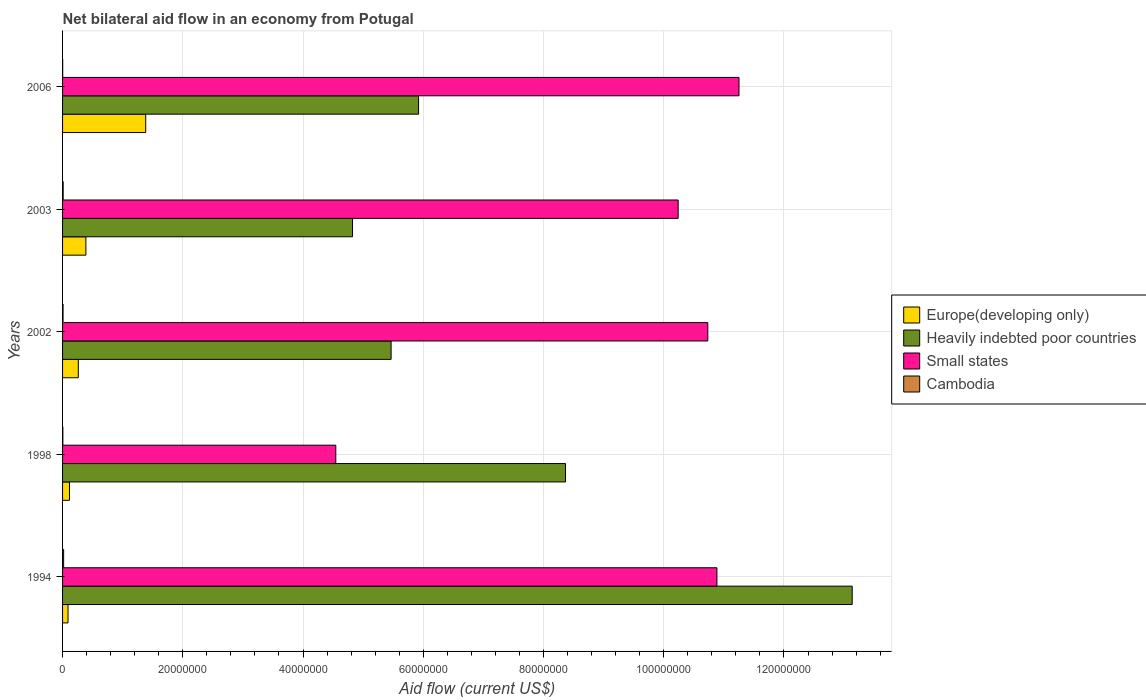How many different coloured bars are there?
Your response must be concise. 4. How many groups of bars are there?
Provide a short and direct response. 5. Are the number of bars on each tick of the Y-axis equal?
Your answer should be compact. Yes. How many bars are there on the 4th tick from the top?
Ensure brevity in your answer.  4. How many bars are there on the 5th tick from the bottom?
Offer a terse response. 4. What is the label of the 3rd group of bars from the top?
Provide a succinct answer. 2002. In how many cases, is the number of bars for a given year not equal to the number of legend labels?
Offer a very short reply. 0. What is the net bilateral aid flow in Small states in 1998?
Your response must be concise. 4.54e+07. Across all years, what is the maximum net bilateral aid flow in Heavily indebted poor countries?
Your response must be concise. 1.31e+08. Across all years, what is the minimum net bilateral aid flow in Europe(developing only)?
Offer a terse response. 9.10e+05. In which year was the net bilateral aid flow in Europe(developing only) maximum?
Provide a short and direct response. 2006. What is the total net bilateral aid flow in Europe(developing only) in the graph?
Give a very brief answer. 2.24e+07. What is the difference between the net bilateral aid flow in Cambodia in 2002 and that in 2006?
Make the answer very short. 6.00e+04. What is the difference between the net bilateral aid flow in Heavily indebted poor countries in 1998 and the net bilateral aid flow in Cambodia in 2002?
Your answer should be compact. 8.36e+07. What is the average net bilateral aid flow in Heavily indebted poor countries per year?
Make the answer very short. 7.54e+07. In the year 2003, what is the difference between the net bilateral aid flow in Small states and net bilateral aid flow in Europe(developing only)?
Keep it short and to the point. 9.85e+07. In how many years, is the net bilateral aid flow in Cambodia greater than 116000000 US$?
Ensure brevity in your answer.  0. Is the net bilateral aid flow in Heavily indebted poor countries in 2002 less than that in 2003?
Provide a short and direct response. No. Is the difference between the net bilateral aid flow in Small states in 1998 and 2006 greater than the difference between the net bilateral aid flow in Europe(developing only) in 1998 and 2006?
Provide a succinct answer. No. What is the difference between the highest and the second highest net bilateral aid flow in Small states?
Provide a succinct answer. 3.67e+06. What is the difference between the highest and the lowest net bilateral aid flow in Europe(developing only)?
Your response must be concise. 1.29e+07. Is the sum of the net bilateral aid flow in Europe(developing only) in 1994 and 2003 greater than the maximum net bilateral aid flow in Cambodia across all years?
Offer a very short reply. Yes. What does the 2nd bar from the top in 1998 represents?
Your answer should be compact. Small states. What does the 4th bar from the bottom in 2003 represents?
Offer a terse response. Cambodia. How many bars are there?
Ensure brevity in your answer.  20. Are all the bars in the graph horizontal?
Make the answer very short. Yes. How many years are there in the graph?
Keep it short and to the point. 5. Does the graph contain any zero values?
Offer a very short reply. No. How many legend labels are there?
Your answer should be compact. 4. What is the title of the graph?
Your answer should be compact. Net bilateral aid flow in an economy from Potugal. What is the label or title of the Y-axis?
Offer a very short reply. Years. What is the Aid flow (current US$) in Europe(developing only) in 1994?
Keep it short and to the point. 9.10e+05. What is the Aid flow (current US$) of Heavily indebted poor countries in 1994?
Offer a very short reply. 1.31e+08. What is the Aid flow (current US$) in Small states in 1994?
Provide a succinct answer. 1.09e+08. What is the Aid flow (current US$) of Europe(developing only) in 1998?
Offer a very short reply. 1.15e+06. What is the Aid flow (current US$) of Heavily indebted poor countries in 1998?
Give a very brief answer. 8.37e+07. What is the Aid flow (current US$) in Small states in 1998?
Provide a short and direct response. 4.54e+07. What is the Aid flow (current US$) of Cambodia in 1998?
Offer a terse response. 5.00e+04. What is the Aid flow (current US$) of Europe(developing only) in 2002?
Provide a succinct answer. 2.62e+06. What is the Aid flow (current US$) in Heavily indebted poor countries in 2002?
Offer a terse response. 5.46e+07. What is the Aid flow (current US$) in Small states in 2002?
Keep it short and to the point. 1.07e+08. What is the Aid flow (current US$) in Europe(developing only) in 2003?
Offer a very short reply. 3.88e+06. What is the Aid flow (current US$) in Heavily indebted poor countries in 2003?
Offer a terse response. 4.82e+07. What is the Aid flow (current US$) in Small states in 2003?
Make the answer very short. 1.02e+08. What is the Aid flow (current US$) in Cambodia in 2003?
Your answer should be very brief. 1.00e+05. What is the Aid flow (current US$) of Europe(developing only) in 2006?
Offer a very short reply. 1.38e+07. What is the Aid flow (current US$) of Heavily indebted poor countries in 2006?
Your answer should be compact. 5.92e+07. What is the Aid flow (current US$) of Small states in 2006?
Your answer should be compact. 1.13e+08. Across all years, what is the maximum Aid flow (current US$) in Europe(developing only)?
Provide a short and direct response. 1.38e+07. Across all years, what is the maximum Aid flow (current US$) in Heavily indebted poor countries?
Make the answer very short. 1.31e+08. Across all years, what is the maximum Aid flow (current US$) in Small states?
Ensure brevity in your answer.  1.13e+08. Across all years, what is the maximum Aid flow (current US$) in Cambodia?
Offer a terse response. 1.80e+05. Across all years, what is the minimum Aid flow (current US$) in Europe(developing only)?
Ensure brevity in your answer.  9.10e+05. Across all years, what is the minimum Aid flow (current US$) of Heavily indebted poor countries?
Make the answer very short. 4.82e+07. Across all years, what is the minimum Aid flow (current US$) of Small states?
Provide a short and direct response. 4.54e+07. What is the total Aid flow (current US$) in Europe(developing only) in the graph?
Offer a very short reply. 2.24e+07. What is the total Aid flow (current US$) of Heavily indebted poor countries in the graph?
Provide a succinct answer. 3.77e+08. What is the total Aid flow (current US$) of Small states in the graph?
Offer a very short reply. 4.77e+08. What is the difference between the Aid flow (current US$) in Heavily indebted poor countries in 1994 and that in 1998?
Give a very brief answer. 4.77e+07. What is the difference between the Aid flow (current US$) in Small states in 1994 and that in 1998?
Give a very brief answer. 6.34e+07. What is the difference between the Aid flow (current US$) in Europe(developing only) in 1994 and that in 2002?
Make the answer very short. -1.71e+06. What is the difference between the Aid flow (current US$) in Heavily indebted poor countries in 1994 and that in 2002?
Your response must be concise. 7.67e+07. What is the difference between the Aid flow (current US$) in Small states in 1994 and that in 2002?
Keep it short and to the point. 1.52e+06. What is the difference between the Aid flow (current US$) in Cambodia in 1994 and that in 2002?
Ensure brevity in your answer.  1.00e+05. What is the difference between the Aid flow (current US$) of Europe(developing only) in 1994 and that in 2003?
Offer a terse response. -2.97e+06. What is the difference between the Aid flow (current US$) in Heavily indebted poor countries in 1994 and that in 2003?
Offer a terse response. 8.31e+07. What is the difference between the Aid flow (current US$) in Small states in 1994 and that in 2003?
Give a very brief answer. 6.45e+06. What is the difference between the Aid flow (current US$) in Europe(developing only) in 1994 and that in 2006?
Your answer should be very brief. -1.29e+07. What is the difference between the Aid flow (current US$) of Heavily indebted poor countries in 1994 and that in 2006?
Offer a terse response. 7.21e+07. What is the difference between the Aid flow (current US$) in Small states in 1994 and that in 2006?
Your response must be concise. -3.67e+06. What is the difference between the Aid flow (current US$) in Europe(developing only) in 1998 and that in 2002?
Give a very brief answer. -1.47e+06. What is the difference between the Aid flow (current US$) in Heavily indebted poor countries in 1998 and that in 2002?
Your answer should be very brief. 2.90e+07. What is the difference between the Aid flow (current US$) of Small states in 1998 and that in 2002?
Your answer should be very brief. -6.19e+07. What is the difference between the Aid flow (current US$) in Europe(developing only) in 1998 and that in 2003?
Your response must be concise. -2.73e+06. What is the difference between the Aid flow (current US$) of Heavily indebted poor countries in 1998 and that in 2003?
Your answer should be very brief. 3.54e+07. What is the difference between the Aid flow (current US$) of Small states in 1998 and that in 2003?
Keep it short and to the point. -5.70e+07. What is the difference between the Aid flow (current US$) of Cambodia in 1998 and that in 2003?
Keep it short and to the point. -5.00e+04. What is the difference between the Aid flow (current US$) in Europe(developing only) in 1998 and that in 2006?
Provide a succinct answer. -1.27e+07. What is the difference between the Aid flow (current US$) of Heavily indebted poor countries in 1998 and that in 2006?
Your response must be concise. 2.44e+07. What is the difference between the Aid flow (current US$) of Small states in 1998 and that in 2006?
Provide a succinct answer. -6.71e+07. What is the difference between the Aid flow (current US$) of Cambodia in 1998 and that in 2006?
Offer a very short reply. 3.00e+04. What is the difference between the Aid flow (current US$) in Europe(developing only) in 2002 and that in 2003?
Make the answer very short. -1.26e+06. What is the difference between the Aid flow (current US$) of Heavily indebted poor countries in 2002 and that in 2003?
Your answer should be very brief. 6.42e+06. What is the difference between the Aid flow (current US$) of Small states in 2002 and that in 2003?
Provide a short and direct response. 4.93e+06. What is the difference between the Aid flow (current US$) in Europe(developing only) in 2002 and that in 2006?
Your answer should be compact. -1.12e+07. What is the difference between the Aid flow (current US$) of Heavily indebted poor countries in 2002 and that in 2006?
Provide a short and direct response. -4.57e+06. What is the difference between the Aid flow (current US$) of Small states in 2002 and that in 2006?
Offer a terse response. -5.19e+06. What is the difference between the Aid flow (current US$) in Europe(developing only) in 2003 and that in 2006?
Make the answer very short. -9.95e+06. What is the difference between the Aid flow (current US$) in Heavily indebted poor countries in 2003 and that in 2006?
Keep it short and to the point. -1.10e+07. What is the difference between the Aid flow (current US$) in Small states in 2003 and that in 2006?
Your answer should be very brief. -1.01e+07. What is the difference between the Aid flow (current US$) in Europe(developing only) in 1994 and the Aid flow (current US$) in Heavily indebted poor countries in 1998?
Offer a very short reply. -8.28e+07. What is the difference between the Aid flow (current US$) of Europe(developing only) in 1994 and the Aid flow (current US$) of Small states in 1998?
Offer a terse response. -4.45e+07. What is the difference between the Aid flow (current US$) in Europe(developing only) in 1994 and the Aid flow (current US$) in Cambodia in 1998?
Your answer should be compact. 8.60e+05. What is the difference between the Aid flow (current US$) of Heavily indebted poor countries in 1994 and the Aid flow (current US$) of Small states in 1998?
Give a very brief answer. 8.59e+07. What is the difference between the Aid flow (current US$) in Heavily indebted poor countries in 1994 and the Aid flow (current US$) in Cambodia in 1998?
Provide a short and direct response. 1.31e+08. What is the difference between the Aid flow (current US$) of Small states in 1994 and the Aid flow (current US$) of Cambodia in 1998?
Ensure brevity in your answer.  1.09e+08. What is the difference between the Aid flow (current US$) of Europe(developing only) in 1994 and the Aid flow (current US$) of Heavily indebted poor countries in 2002?
Offer a terse response. -5.37e+07. What is the difference between the Aid flow (current US$) in Europe(developing only) in 1994 and the Aid flow (current US$) in Small states in 2002?
Your answer should be compact. -1.06e+08. What is the difference between the Aid flow (current US$) of Europe(developing only) in 1994 and the Aid flow (current US$) of Cambodia in 2002?
Provide a succinct answer. 8.30e+05. What is the difference between the Aid flow (current US$) in Heavily indebted poor countries in 1994 and the Aid flow (current US$) in Small states in 2002?
Offer a very short reply. 2.40e+07. What is the difference between the Aid flow (current US$) of Heavily indebted poor countries in 1994 and the Aid flow (current US$) of Cambodia in 2002?
Give a very brief answer. 1.31e+08. What is the difference between the Aid flow (current US$) of Small states in 1994 and the Aid flow (current US$) of Cambodia in 2002?
Give a very brief answer. 1.09e+08. What is the difference between the Aid flow (current US$) of Europe(developing only) in 1994 and the Aid flow (current US$) of Heavily indebted poor countries in 2003?
Your answer should be compact. -4.73e+07. What is the difference between the Aid flow (current US$) in Europe(developing only) in 1994 and the Aid flow (current US$) in Small states in 2003?
Provide a succinct answer. -1.01e+08. What is the difference between the Aid flow (current US$) in Europe(developing only) in 1994 and the Aid flow (current US$) in Cambodia in 2003?
Keep it short and to the point. 8.10e+05. What is the difference between the Aid flow (current US$) in Heavily indebted poor countries in 1994 and the Aid flow (current US$) in Small states in 2003?
Provide a succinct answer. 2.90e+07. What is the difference between the Aid flow (current US$) in Heavily indebted poor countries in 1994 and the Aid flow (current US$) in Cambodia in 2003?
Your answer should be very brief. 1.31e+08. What is the difference between the Aid flow (current US$) in Small states in 1994 and the Aid flow (current US$) in Cambodia in 2003?
Provide a succinct answer. 1.09e+08. What is the difference between the Aid flow (current US$) of Europe(developing only) in 1994 and the Aid flow (current US$) of Heavily indebted poor countries in 2006?
Keep it short and to the point. -5.83e+07. What is the difference between the Aid flow (current US$) in Europe(developing only) in 1994 and the Aid flow (current US$) in Small states in 2006?
Make the answer very short. -1.12e+08. What is the difference between the Aid flow (current US$) in Europe(developing only) in 1994 and the Aid flow (current US$) in Cambodia in 2006?
Your answer should be very brief. 8.90e+05. What is the difference between the Aid flow (current US$) of Heavily indebted poor countries in 1994 and the Aid flow (current US$) of Small states in 2006?
Offer a terse response. 1.88e+07. What is the difference between the Aid flow (current US$) in Heavily indebted poor countries in 1994 and the Aid flow (current US$) in Cambodia in 2006?
Your answer should be compact. 1.31e+08. What is the difference between the Aid flow (current US$) of Small states in 1994 and the Aid flow (current US$) of Cambodia in 2006?
Keep it short and to the point. 1.09e+08. What is the difference between the Aid flow (current US$) in Europe(developing only) in 1998 and the Aid flow (current US$) in Heavily indebted poor countries in 2002?
Provide a short and direct response. -5.35e+07. What is the difference between the Aid flow (current US$) of Europe(developing only) in 1998 and the Aid flow (current US$) of Small states in 2002?
Keep it short and to the point. -1.06e+08. What is the difference between the Aid flow (current US$) of Europe(developing only) in 1998 and the Aid flow (current US$) of Cambodia in 2002?
Your answer should be very brief. 1.07e+06. What is the difference between the Aid flow (current US$) of Heavily indebted poor countries in 1998 and the Aid flow (current US$) of Small states in 2002?
Give a very brief answer. -2.37e+07. What is the difference between the Aid flow (current US$) in Heavily indebted poor countries in 1998 and the Aid flow (current US$) in Cambodia in 2002?
Make the answer very short. 8.36e+07. What is the difference between the Aid flow (current US$) of Small states in 1998 and the Aid flow (current US$) of Cambodia in 2002?
Make the answer very short. 4.54e+07. What is the difference between the Aid flow (current US$) of Europe(developing only) in 1998 and the Aid flow (current US$) of Heavily indebted poor countries in 2003?
Your response must be concise. -4.71e+07. What is the difference between the Aid flow (current US$) of Europe(developing only) in 1998 and the Aid flow (current US$) of Small states in 2003?
Make the answer very short. -1.01e+08. What is the difference between the Aid flow (current US$) in Europe(developing only) in 1998 and the Aid flow (current US$) in Cambodia in 2003?
Ensure brevity in your answer.  1.05e+06. What is the difference between the Aid flow (current US$) of Heavily indebted poor countries in 1998 and the Aid flow (current US$) of Small states in 2003?
Keep it short and to the point. -1.87e+07. What is the difference between the Aid flow (current US$) of Heavily indebted poor countries in 1998 and the Aid flow (current US$) of Cambodia in 2003?
Your answer should be very brief. 8.36e+07. What is the difference between the Aid flow (current US$) of Small states in 1998 and the Aid flow (current US$) of Cambodia in 2003?
Your response must be concise. 4.54e+07. What is the difference between the Aid flow (current US$) of Europe(developing only) in 1998 and the Aid flow (current US$) of Heavily indebted poor countries in 2006?
Offer a very short reply. -5.81e+07. What is the difference between the Aid flow (current US$) of Europe(developing only) in 1998 and the Aid flow (current US$) of Small states in 2006?
Keep it short and to the point. -1.11e+08. What is the difference between the Aid flow (current US$) in Europe(developing only) in 1998 and the Aid flow (current US$) in Cambodia in 2006?
Ensure brevity in your answer.  1.13e+06. What is the difference between the Aid flow (current US$) of Heavily indebted poor countries in 1998 and the Aid flow (current US$) of Small states in 2006?
Provide a short and direct response. -2.89e+07. What is the difference between the Aid flow (current US$) in Heavily indebted poor countries in 1998 and the Aid flow (current US$) in Cambodia in 2006?
Give a very brief answer. 8.36e+07. What is the difference between the Aid flow (current US$) in Small states in 1998 and the Aid flow (current US$) in Cambodia in 2006?
Ensure brevity in your answer.  4.54e+07. What is the difference between the Aid flow (current US$) in Europe(developing only) in 2002 and the Aid flow (current US$) in Heavily indebted poor countries in 2003?
Give a very brief answer. -4.56e+07. What is the difference between the Aid flow (current US$) in Europe(developing only) in 2002 and the Aid flow (current US$) in Small states in 2003?
Your response must be concise. -9.98e+07. What is the difference between the Aid flow (current US$) in Europe(developing only) in 2002 and the Aid flow (current US$) in Cambodia in 2003?
Provide a succinct answer. 2.52e+06. What is the difference between the Aid flow (current US$) in Heavily indebted poor countries in 2002 and the Aid flow (current US$) in Small states in 2003?
Your response must be concise. -4.78e+07. What is the difference between the Aid flow (current US$) in Heavily indebted poor countries in 2002 and the Aid flow (current US$) in Cambodia in 2003?
Offer a very short reply. 5.46e+07. What is the difference between the Aid flow (current US$) in Small states in 2002 and the Aid flow (current US$) in Cambodia in 2003?
Ensure brevity in your answer.  1.07e+08. What is the difference between the Aid flow (current US$) of Europe(developing only) in 2002 and the Aid flow (current US$) of Heavily indebted poor countries in 2006?
Provide a succinct answer. -5.66e+07. What is the difference between the Aid flow (current US$) of Europe(developing only) in 2002 and the Aid flow (current US$) of Small states in 2006?
Your answer should be compact. -1.10e+08. What is the difference between the Aid flow (current US$) in Europe(developing only) in 2002 and the Aid flow (current US$) in Cambodia in 2006?
Offer a very short reply. 2.60e+06. What is the difference between the Aid flow (current US$) of Heavily indebted poor countries in 2002 and the Aid flow (current US$) of Small states in 2006?
Keep it short and to the point. -5.79e+07. What is the difference between the Aid flow (current US$) of Heavily indebted poor countries in 2002 and the Aid flow (current US$) of Cambodia in 2006?
Keep it short and to the point. 5.46e+07. What is the difference between the Aid flow (current US$) of Small states in 2002 and the Aid flow (current US$) of Cambodia in 2006?
Your answer should be very brief. 1.07e+08. What is the difference between the Aid flow (current US$) in Europe(developing only) in 2003 and the Aid flow (current US$) in Heavily indebted poor countries in 2006?
Provide a succinct answer. -5.53e+07. What is the difference between the Aid flow (current US$) in Europe(developing only) in 2003 and the Aid flow (current US$) in Small states in 2006?
Make the answer very short. -1.09e+08. What is the difference between the Aid flow (current US$) in Europe(developing only) in 2003 and the Aid flow (current US$) in Cambodia in 2006?
Ensure brevity in your answer.  3.86e+06. What is the difference between the Aid flow (current US$) of Heavily indebted poor countries in 2003 and the Aid flow (current US$) of Small states in 2006?
Give a very brief answer. -6.43e+07. What is the difference between the Aid flow (current US$) of Heavily indebted poor countries in 2003 and the Aid flow (current US$) of Cambodia in 2006?
Offer a very short reply. 4.82e+07. What is the difference between the Aid flow (current US$) of Small states in 2003 and the Aid flow (current US$) of Cambodia in 2006?
Give a very brief answer. 1.02e+08. What is the average Aid flow (current US$) of Europe(developing only) per year?
Make the answer very short. 4.48e+06. What is the average Aid flow (current US$) of Heavily indebted poor countries per year?
Provide a succinct answer. 7.54e+07. What is the average Aid flow (current US$) in Small states per year?
Ensure brevity in your answer.  9.53e+07. What is the average Aid flow (current US$) of Cambodia per year?
Offer a terse response. 8.60e+04. In the year 1994, what is the difference between the Aid flow (current US$) of Europe(developing only) and Aid flow (current US$) of Heavily indebted poor countries?
Your response must be concise. -1.30e+08. In the year 1994, what is the difference between the Aid flow (current US$) of Europe(developing only) and Aid flow (current US$) of Small states?
Give a very brief answer. -1.08e+08. In the year 1994, what is the difference between the Aid flow (current US$) in Europe(developing only) and Aid flow (current US$) in Cambodia?
Your response must be concise. 7.30e+05. In the year 1994, what is the difference between the Aid flow (current US$) of Heavily indebted poor countries and Aid flow (current US$) of Small states?
Offer a terse response. 2.25e+07. In the year 1994, what is the difference between the Aid flow (current US$) in Heavily indebted poor countries and Aid flow (current US$) in Cambodia?
Keep it short and to the point. 1.31e+08. In the year 1994, what is the difference between the Aid flow (current US$) of Small states and Aid flow (current US$) of Cambodia?
Your answer should be compact. 1.09e+08. In the year 1998, what is the difference between the Aid flow (current US$) in Europe(developing only) and Aid flow (current US$) in Heavily indebted poor countries?
Provide a succinct answer. -8.25e+07. In the year 1998, what is the difference between the Aid flow (current US$) in Europe(developing only) and Aid flow (current US$) in Small states?
Make the answer very short. -4.43e+07. In the year 1998, what is the difference between the Aid flow (current US$) in Europe(developing only) and Aid flow (current US$) in Cambodia?
Keep it short and to the point. 1.10e+06. In the year 1998, what is the difference between the Aid flow (current US$) of Heavily indebted poor countries and Aid flow (current US$) of Small states?
Keep it short and to the point. 3.82e+07. In the year 1998, what is the difference between the Aid flow (current US$) of Heavily indebted poor countries and Aid flow (current US$) of Cambodia?
Your answer should be very brief. 8.36e+07. In the year 1998, what is the difference between the Aid flow (current US$) in Small states and Aid flow (current US$) in Cambodia?
Provide a succinct answer. 4.54e+07. In the year 2002, what is the difference between the Aid flow (current US$) of Europe(developing only) and Aid flow (current US$) of Heavily indebted poor countries?
Offer a very short reply. -5.20e+07. In the year 2002, what is the difference between the Aid flow (current US$) of Europe(developing only) and Aid flow (current US$) of Small states?
Provide a succinct answer. -1.05e+08. In the year 2002, what is the difference between the Aid flow (current US$) of Europe(developing only) and Aid flow (current US$) of Cambodia?
Give a very brief answer. 2.54e+06. In the year 2002, what is the difference between the Aid flow (current US$) in Heavily indebted poor countries and Aid flow (current US$) in Small states?
Make the answer very short. -5.27e+07. In the year 2002, what is the difference between the Aid flow (current US$) in Heavily indebted poor countries and Aid flow (current US$) in Cambodia?
Your answer should be very brief. 5.46e+07. In the year 2002, what is the difference between the Aid flow (current US$) of Small states and Aid flow (current US$) of Cambodia?
Your answer should be very brief. 1.07e+08. In the year 2003, what is the difference between the Aid flow (current US$) in Europe(developing only) and Aid flow (current US$) in Heavily indebted poor countries?
Make the answer very short. -4.44e+07. In the year 2003, what is the difference between the Aid flow (current US$) in Europe(developing only) and Aid flow (current US$) in Small states?
Offer a terse response. -9.85e+07. In the year 2003, what is the difference between the Aid flow (current US$) in Europe(developing only) and Aid flow (current US$) in Cambodia?
Provide a succinct answer. 3.78e+06. In the year 2003, what is the difference between the Aid flow (current US$) in Heavily indebted poor countries and Aid flow (current US$) in Small states?
Keep it short and to the point. -5.42e+07. In the year 2003, what is the difference between the Aid flow (current US$) in Heavily indebted poor countries and Aid flow (current US$) in Cambodia?
Your response must be concise. 4.81e+07. In the year 2003, what is the difference between the Aid flow (current US$) of Small states and Aid flow (current US$) of Cambodia?
Your answer should be compact. 1.02e+08. In the year 2006, what is the difference between the Aid flow (current US$) of Europe(developing only) and Aid flow (current US$) of Heavily indebted poor countries?
Give a very brief answer. -4.54e+07. In the year 2006, what is the difference between the Aid flow (current US$) in Europe(developing only) and Aid flow (current US$) in Small states?
Keep it short and to the point. -9.87e+07. In the year 2006, what is the difference between the Aid flow (current US$) in Europe(developing only) and Aid flow (current US$) in Cambodia?
Ensure brevity in your answer.  1.38e+07. In the year 2006, what is the difference between the Aid flow (current US$) of Heavily indebted poor countries and Aid flow (current US$) of Small states?
Your answer should be very brief. -5.33e+07. In the year 2006, what is the difference between the Aid flow (current US$) in Heavily indebted poor countries and Aid flow (current US$) in Cambodia?
Provide a short and direct response. 5.92e+07. In the year 2006, what is the difference between the Aid flow (current US$) of Small states and Aid flow (current US$) of Cambodia?
Ensure brevity in your answer.  1.12e+08. What is the ratio of the Aid flow (current US$) in Europe(developing only) in 1994 to that in 1998?
Offer a very short reply. 0.79. What is the ratio of the Aid flow (current US$) in Heavily indebted poor countries in 1994 to that in 1998?
Offer a very short reply. 1.57. What is the ratio of the Aid flow (current US$) of Small states in 1994 to that in 1998?
Provide a short and direct response. 2.39. What is the ratio of the Aid flow (current US$) in Europe(developing only) in 1994 to that in 2002?
Make the answer very short. 0.35. What is the ratio of the Aid flow (current US$) of Heavily indebted poor countries in 1994 to that in 2002?
Your response must be concise. 2.4. What is the ratio of the Aid flow (current US$) in Small states in 1994 to that in 2002?
Offer a terse response. 1.01. What is the ratio of the Aid flow (current US$) in Cambodia in 1994 to that in 2002?
Provide a short and direct response. 2.25. What is the ratio of the Aid flow (current US$) of Europe(developing only) in 1994 to that in 2003?
Offer a terse response. 0.23. What is the ratio of the Aid flow (current US$) in Heavily indebted poor countries in 1994 to that in 2003?
Give a very brief answer. 2.72. What is the ratio of the Aid flow (current US$) in Small states in 1994 to that in 2003?
Offer a terse response. 1.06. What is the ratio of the Aid flow (current US$) of Cambodia in 1994 to that in 2003?
Offer a very short reply. 1.8. What is the ratio of the Aid flow (current US$) of Europe(developing only) in 1994 to that in 2006?
Make the answer very short. 0.07. What is the ratio of the Aid flow (current US$) of Heavily indebted poor countries in 1994 to that in 2006?
Give a very brief answer. 2.22. What is the ratio of the Aid flow (current US$) of Small states in 1994 to that in 2006?
Ensure brevity in your answer.  0.97. What is the ratio of the Aid flow (current US$) in Europe(developing only) in 1998 to that in 2002?
Make the answer very short. 0.44. What is the ratio of the Aid flow (current US$) of Heavily indebted poor countries in 1998 to that in 2002?
Ensure brevity in your answer.  1.53. What is the ratio of the Aid flow (current US$) of Small states in 1998 to that in 2002?
Make the answer very short. 0.42. What is the ratio of the Aid flow (current US$) in Cambodia in 1998 to that in 2002?
Provide a succinct answer. 0.62. What is the ratio of the Aid flow (current US$) of Europe(developing only) in 1998 to that in 2003?
Provide a short and direct response. 0.3. What is the ratio of the Aid flow (current US$) in Heavily indebted poor countries in 1998 to that in 2003?
Make the answer very short. 1.73. What is the ratio of the Aid flow (current US$) of Small states in 1998 to that in 2003?
Keep it short and to the point. 0.44. What is the ratio of the Aid flow (current US$) of Europe(developing only) in 1998 to that in 2006?
Provide a short and direct response. 0.08. What is the ratio of the Aid flow (current US$) of Heavily indebted poor countries in 1998 to that in 2006?
Keep it short and to the point. 1.41. What is the ratio of the Aid flow (current US$) in Small states in 1998 to that in 2006?
Offer a terse response. 0.4. What is the ratio of the Aid flow (current US$) in Europe(developing only) in 2002 to that in 2003?
Ensure brevity in your answer.  0.68. What is the ratio of the Aid flow (current US$) of Heavily indebted poor countries in 2002 to that in 2003?
Provide a succinct answer. 1.13. What is the ratio of the Aid flow (current US$) of Small states in 2002 to that in 2003?
Give a very brief answer. 1.05. What is the ratio of the Aid flow (current US$) of Cambodia in 2002 to that in 2003?
Make the answer very short. 0.8. What is the ratio of the Aid flow (current US$) in Europe(developing only) in 2002 to that in 2006?
Offer a very short reply. 0.19. What is the ratio of the Aid flow (current US$) of Heavily indebted poor countries in 2002 to that in 2006?
Your answer should be compact. 0.92. What is the ratio of the Aid flow (current US$) of Small states in 2002 to that in 2006?
Make the answer very short. 0.95. What is the ratio of the Aid flow (current US$) of Cambodia in 2002 to that in 2006?
Provide a short and direct response. 4. What is the ratio of the Aid flow (current US$) of Europe(developing only) in 2003 to that in 2006?
Offer a terse response. 0.28. What is the ratio of the Aid flow (current US$) of Heavily indebted poor countries in 2003 to that in 2006?
Make the answer very short. 0.81. What is the ratio of the Aid flow (current US$) of Small states in 2003 to that in 2006?
Your answer should be very brief. 0.91. What is the ratio of the Aid flow (current US$) of Cambodia in 2003 to that in 2006?
Ensure brevity in your answer.  5. What is the difference between the highest and the second highest Aid flow (current US$) in Europe(developing only)?
Ensure brevity in your answer.  9.95e+06. What is the difference between the highest and the second highest Aid flow (current US$) of Heavily indebted poor countries?
Your answer should be compact. 4.77e+07. What is the difference between the highest and the second highest Aid flow (current US$) in Small states?
Make the answer very short. 3.67e+06. What is the difference between the highest and the second highest Aid flow (current US$) in Cambodia?
Provide a short and direct response. 8.00e+04. What is the difference between the highest and the lowest Aid flow (current US$) in Europe(developing only)?
Provide a short and direct response. 1.29e+07. What is the difference between the highest and the lowest Aid flow (current US$) of Heavily indebted poor countries?
Your answer should be very brief. 8.31e+07. What is the difference between the highest and the lowest Aid flow (current US$) in Small states?
Give a very brief answer. 6.71e+07. What is the difference between the highest and the lowest Aid flow (current US$) of Cambodia?
Make the answer very short. 1.60e+05. 